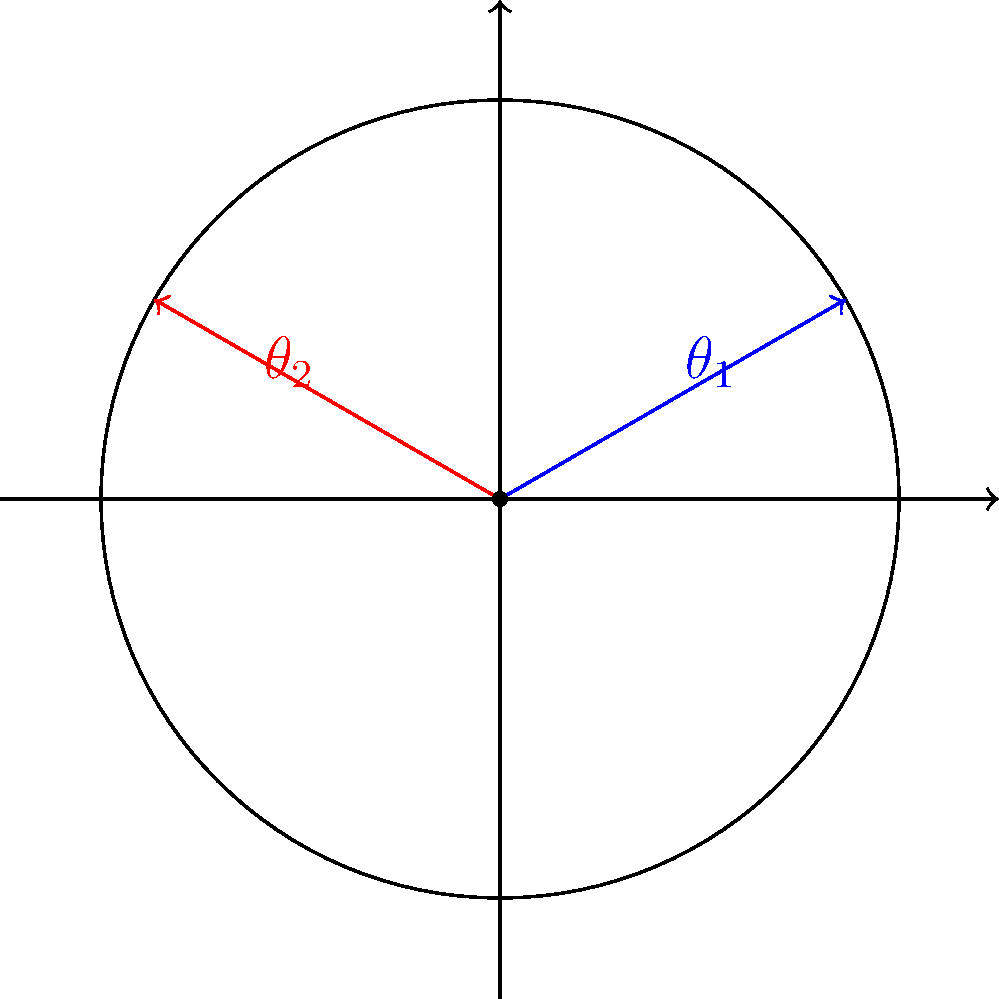In a traditional pin tumbler lock, the cam rotates to engage or disengage the bolt. Consider a lock where the initial position of the cam is at angle $\theta_1 = \frac{\pi}{6}$ radians (blue arrow) and the final position after unlocking is at angle $\theta_2 = \frac{5\pi}{6}$ radians (red arrow). What is the total angle of rotation for the cam during the unlocking process? To find the total angle of rotation, we need to follow these steps:

1) Identify the initial and final angles:
   Initial angle: $\theta_1 = \frac{\pi}{6}$ radians
   Final angle: $\theta_2 = \frac{5\pi}{6}$ radians

2) Calculate the difference between the final and initial angles:
   $\Delta \theta = \theta_2 - \theta_1$
   
3) Substitute the values:
   $\Delta \theta = \frac{5\pi}{6} - \frac{\pi}{6}$

4) Simplify:
   $\Delta \theta = \frac{4\pi}{6} = \frac{2\pi}{3}$ radians

5) Convert to degrees (optional, for better understanding):
   $\frac{2\pi}{3}$ radians = $120°$

Therefore, the total angle of rotation for the cam during the unlocking process is $\frac{2\pi}{3}$ radians or 120°.
Answer: $\frac{2\pi}{3}$ radians 